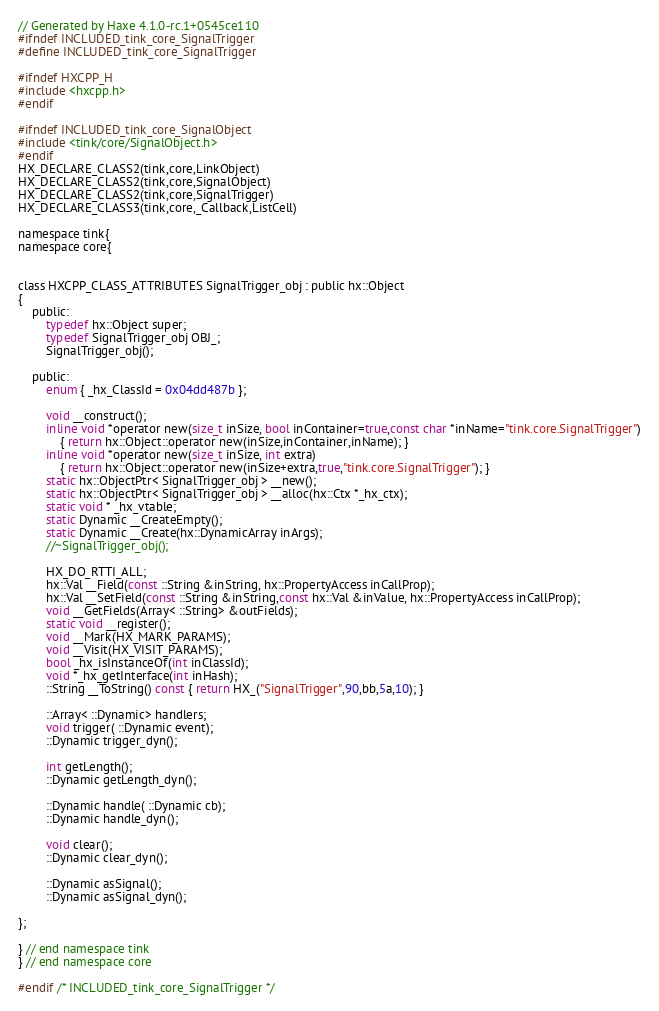<code> <loc_0><loc_0><loc_500><loc_500><_C_>// Generated by Haxe 4.1.0-rc.1+0545ce110
#ifndef INCLUDED_tink_core_SignalTrigger
#define INCLUDED_tink_core_SignalTrigger

#ifndef HXCPP_H
#include <hxcpp.h>
#endif

#ifndef INCLUDED_tink_core_SignalObject
#include <tink/core/SignalObject.h>
#endif
HX_DECLARE_CLASS2(tink,core,LinkObject)
HX_DECLARE_CLASS2(tink,core,SignalObject)
HX_DECLARE_CLASS2(tink,core,SignalTrigger)
HX_DECLARE_CLASS3(tink,core,_Callback,ListCell)

namespace tink{
namespace core{


class HXCPP_CLASS_ATTRIBUTES SignalTrigger_obj : public hx::Object
{
	public:
		typedef hx::Object super;
		typedef SignalTrigger_obj OBJ_;
		SignalTrigger_obj();

	public:
		enum { _hx_ClassId = 0x04dd487b };

		void __construct();
		inline void *operator new(size_t inSize, bool inContainer=true,const char *inName="tink.core.SignalTrigger")
			{ return hx::Object::operator new(inSize,inContainer,inName); }
		inline void *operator new(size_t inSize, int extra)
			{ return hx::Object::operator new(inSize+extra,true,"tink.core.SignalTrigger"); }
		static hx::ObjectPtr< SignalTrigger_obj > __new();
		static hx::ObjectPtr< SignalTrigger_obj > __alloc(hx::Ctx *_hx_ctx);
		static void * _hx_vtable;
		static Dynamic __CreateEmpty();
		static Dynamic __Create(hx::DynamicArray inArgs);
		//~SignalTrigger_obj();

		HX_DO_RTTI_ALL;
		hx::Val __Field(const ::String &inString, hx::PropertyAccess inCallProp);
		hx::Val __SetField(const ::String &inString,const hx::Val &inValue, hx::PropertyAccess inCallProp);
		void __GetFields(Array< ::String> &outFields);
		static void __register();
		void __Mark(HX_MARK_PARAMS);
		void __Visit(HX_VISIT_PARAMS);
		bool _hx_isInstanceOf(int inClassId);
		void *_hx_getInterface(int inHash);
		::String __ToString() const { return HX_("SignalTrigger",90,bb,5a,10); }

		::Array< ::Dynamic> handlers;
		void trigger( ::Dynamic event);
		::Dynamic trigger_dyn();

		int getLength();
		::Dynamic getLength_dyn();

		::Dynamic handle( ::Dynamic cb);
		::Dynamic handle_dyn();

		void clear();
		::Dynamic clear_dyn();

		::Dynamic asSignal();
		::Dynamic asSignal_dyn();

};

} // end namespace tink
} // end namespace core

#endif /* INCLUDED_tink_core_SignalTrigger */ 
</code> 